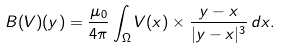<formula> <loc_0><loc_0><loc_500><loc_500>B ( V ) ( y ) = \frac { \mu _ { 0 } } { 4 \pi } \int _ { \Omega } { V ( x ) \times \frac { y - x } { | y - x | ^ { 3 } } \, d x } .</formula> 